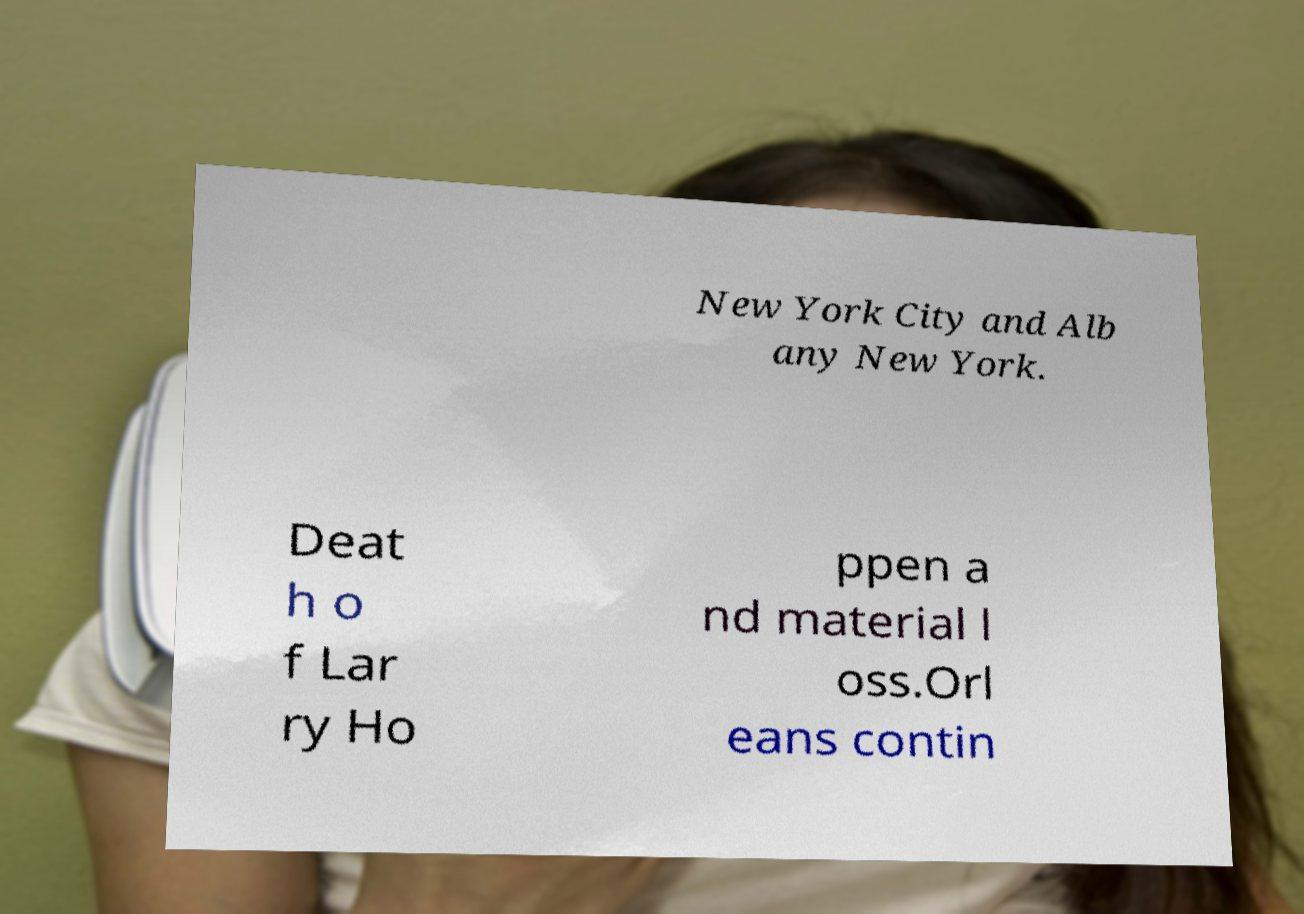For documentation purposes, I need the text within this image transcribed. Could you provide that? New York City and Alb any New York. Deat h o f Lar ry Ho ppen a nd material l oss.Orl eans contin 